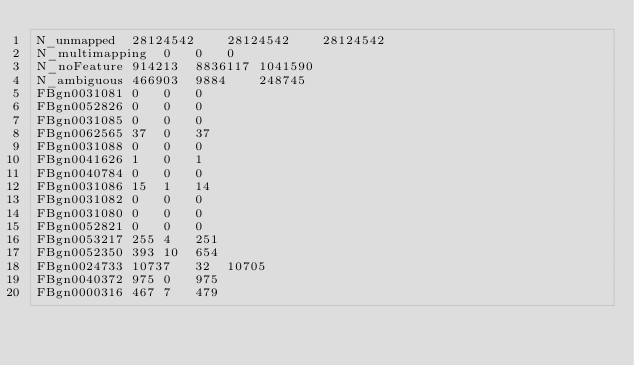Convert code to text. <code><loc_0><loc_0><loc_500><loc_500><_SQL_>N_unmapped	28124542	28124542	28124542
N_multimapping	0	0	0
N_noFeature	914213	8836117	1041590
N_ambiguous	466903	9884	248745
FBgn0031081	0	0	0
FBgn0052826	0	0	0
FBgn0031085	0	0	0
FBgn0062565	37	0	37
FBgn0031088	0	0	0
FBgn0041626	1	0	1
FBgn0040784	0	0	0
FBgn0031086	15	1	14
FBgn0031082	0	0	0
FBgn0031080	0	0	0
FBgn0052821	0	0	0
FBgn0053217	255	4	251
FBgn0052350	393	10	654
FBgn0024733	10737	32	10705
FBgn0040372	975	0	975
FBgn0000316	467	7	479</code> 